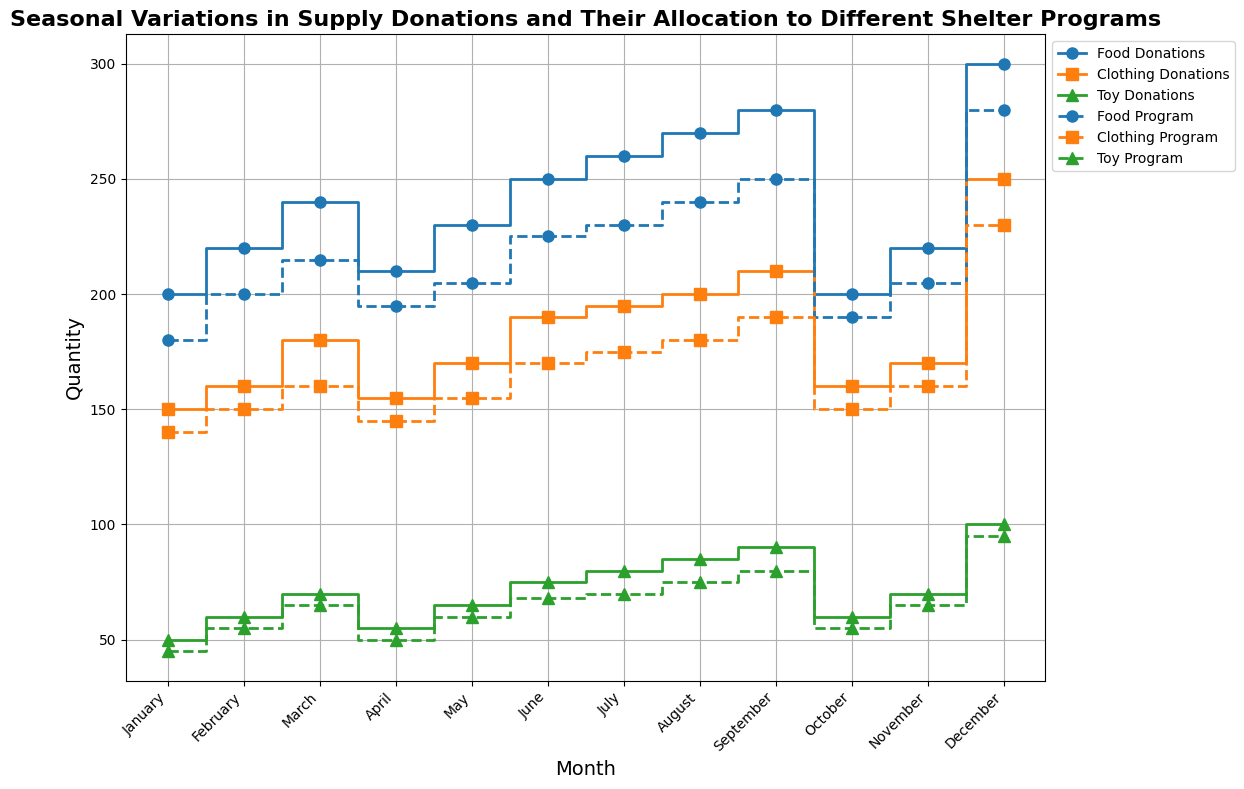How many more food donations were there in December compared to October? To find the difference, subtract the number of food donations in October from those in December, i.e., 300 - 200 = 100.
Answer: 100 Which month had the highest number of clothing donations and how many were there? Look at the clothing donations data and identify the month with the highest value. December had the highest at 250.
Answer: December, 250 Compare the food donations and food program allocations in June. Is there a surplus or deficit? Subtract the food program allocations from the food donations in June, i.e., 250 - 225 = 25 surplus.
Answer: Surplus, 25 Between March and May, which month saw the greatest increase in toy donations from the previous month? Calculate the month-to-month increase for March to May: 
- February to March: 70 - 60 = 10
- March to April: 55 - 70 = -15
- April to May: 65 - 55 = 10 
March saw an increase of 10, which is the greatest positive change.
Answer: March What is the total number of toy donations over the whole year? Sum up all the toy donations for each month:  50 + 60 + 70 + 55 + 65 + 75 + 80 + 85 + 90 + 60 + 70 + 100 = 860.
Answer: 860 Which month experienced the largest drop in clothing donations and what was the amount of the drop? Check for the most substantial month-to-month decrease in clothing donations:
- September to October: 210 - 160 = 50
- April to May: 155 - 170 = -15
The largest drop is from September to October, 50 units.
Answer: October, 50 Did the toy program allocation ever equal toy donations in any month? By visually comparing the toy donations and toy program data, you can see that no month has equal values for both categories.
Answer: No If total donations (sum of food, clothing, and toys) are compared to total program allocations in December, is there a surplus or deficit? Calculate the total donations and total allocations for December:
- Total Donations: 300 + 250 + 100 = 650
- Total Allocations: 280 + 230 + 95 = 605
650 - 605 = 45 surplus.
Answer: Surplus, 45 How many months had more toy donations than toy program allocations? Compare toy donations and toy program allocations month by month:
January, February, March, May, June, July, August, September, November, December have more toy donations than toy program allocations. So, 10 months.
Answer: 10 What is the average food program allocation per month? Sum all food program allocations and divide by 12:
(180 + 200 + 215 + 195 + 205 + 225 + 230 + 240 + 250 + 190 + 205 + 280) / 12 = 2415 / 12 = 201.25.
Answer: 201.25 